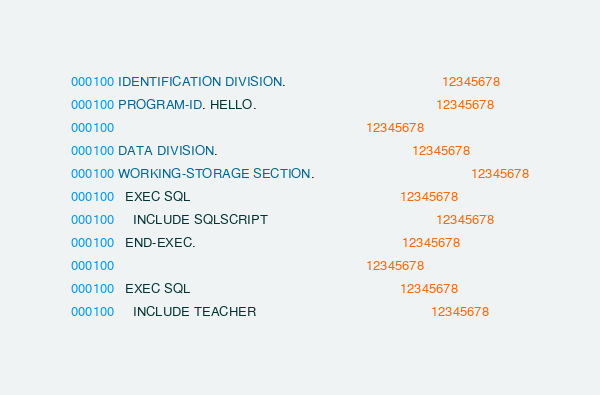Convert code to text. <code><loc_0><loc_0><loc_500><loc_500><_COBOL_>000100 IDENTIFICATION DIVISION.                                         12345678
000100 PROGRAM-ID. HELLO.                                               12345678
000100                                                                  12345678
000100 DATA DIVISION.                                                   12345678
000100 WORKING-STORAGE SECTION.                                         12345678
000100   EXEC SQL                                                       12345678
000100     INCLUDE SQLSCRIPT                                            12345678
000100   END-EXEC.                                                      12345678
000100                                                                  12345678
000100   EXEC SQL                                                       12345678
000100     INCLUDE TEACHER                                              12345678</code> 